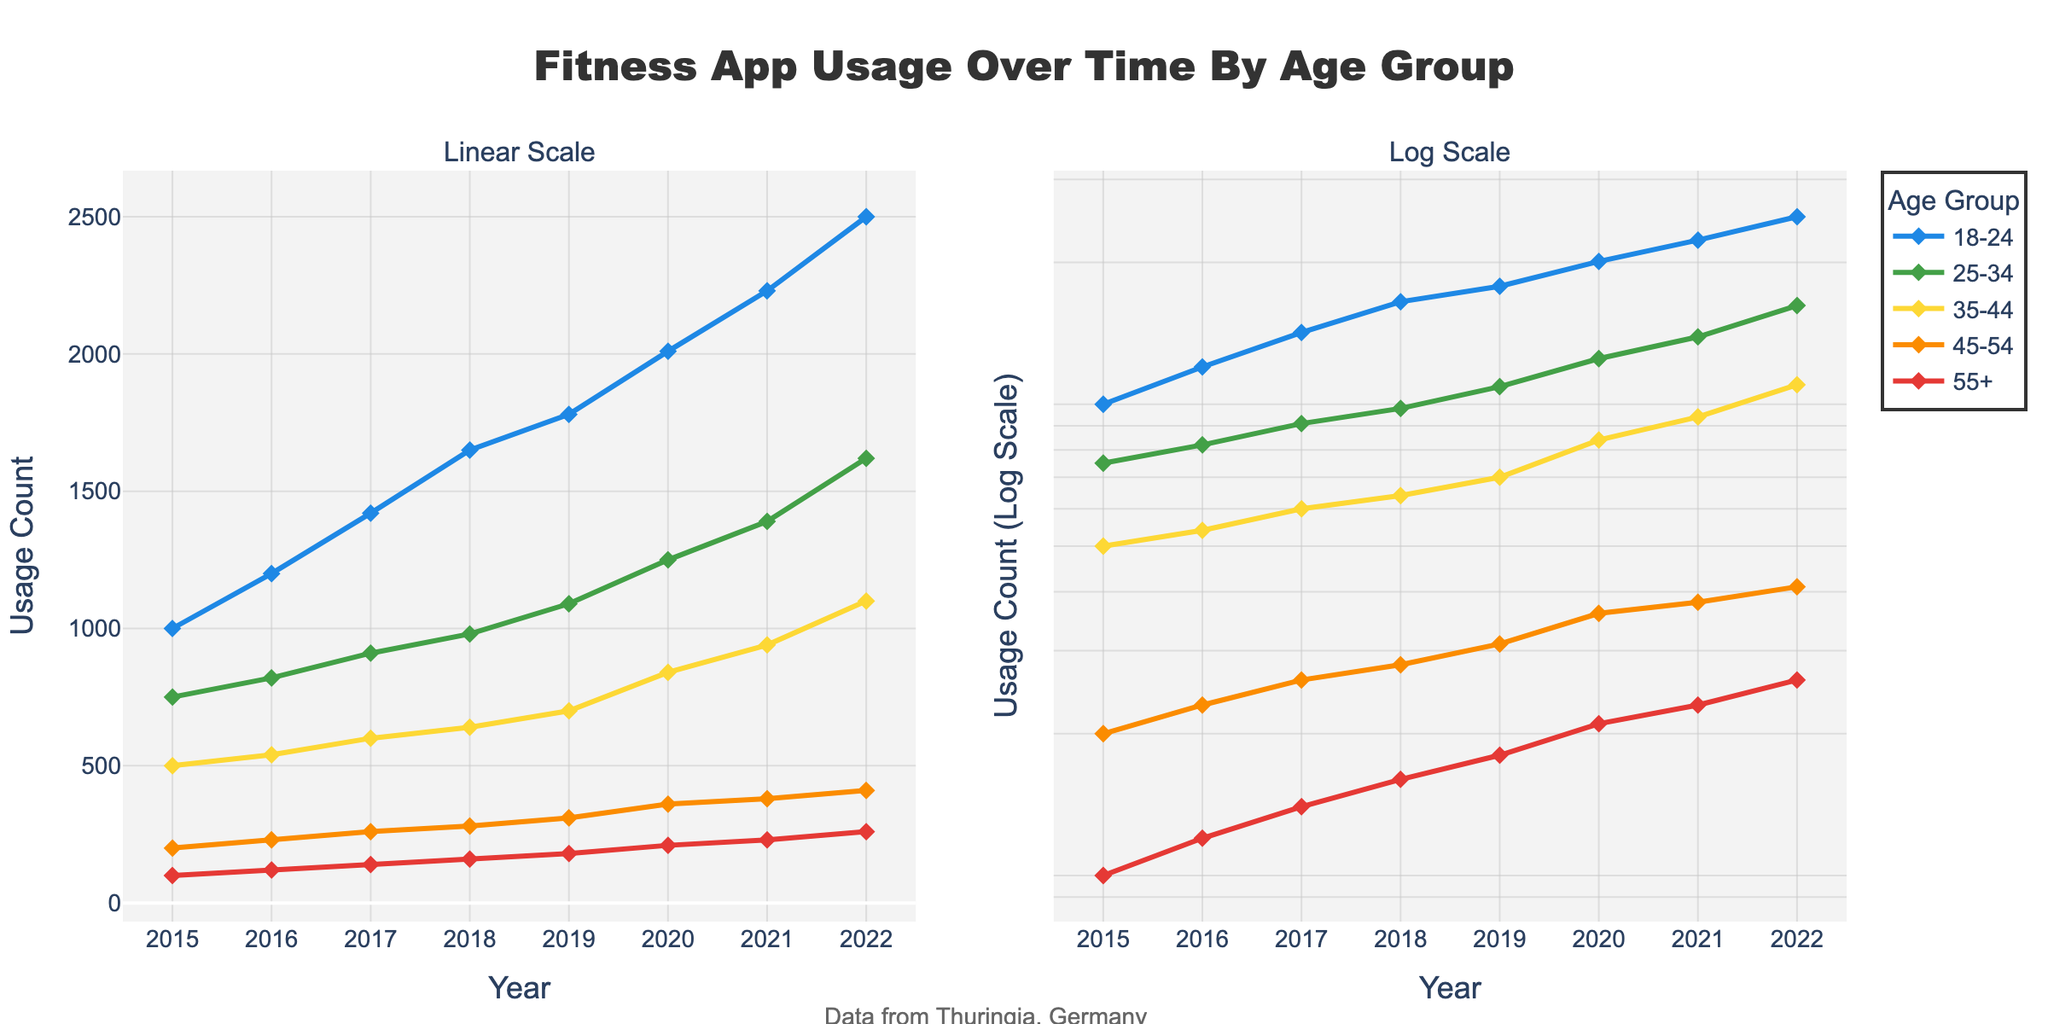What is the title of the figure? The title can be found at the top center of the figure. It reads "Fitness App Usage Over Time By Age Group".
Answer: "Fitness App Usage Over Time By Age Group" What scale types are used for the y-axes in the subplots? The left subplot uses a linear scale for the y-axis, and the right subplot uses a log scale for the y-axis, as indicated by the subplot titles.
Answer: Linear and log scale How many age groups are represented in the figure? The legend shows the different age groups, and from the colors used, we can count five distinct age groups.
Answer: Five Which age group had the highest usage count in 2022? By looking at the endpoints of the lines in 2022, we can see that the age group "18-24" has the highest usage count in both subplots.
Answer: 18-24 What is the log scale usage count for the age group 55+ in 2022? On the log scale (right subplot), the usage count for the age group 55+ in 2022 can be read directly at the 2022 mark; it's around 260.
Answer: 260 How did the usage count for the age group 25-34 change from 2015 to 2022? By comparing the start and end points of the line for age group 25-34, the usage count increased from roughly 750 in 2015 to about 1620 in 2022.
Answer: Increased from 750 to 1620 Which age group shows the steepest increase in usage count over the years? By comparing the slopes of the lines from start to finish, the age group "18-24" shows the steepest increase as evidenced by the sharp rise especially in the latter years.
Answer: 18-24 Between which years did the age group 35-44 show the largest increase in usage count? By evaluating the slope of the line for age group 35-44, the largest increase seems to be between 2020 and 2021.
Answer: 2020 to 2021 Is the usage trend of the age group 45-54 increasing or decreasing? By observing the trend of the line for the age group 45-54, it is evident that the usage count is gradually increasing over the years.
Answer: Increasing Compare the growth rate of the age groups 18-24 and 55+ using the log scale plot. In the log scale subplot on the right, the growth rate is visualized as the slope of the lines; the age group 18-24 shows a much steeper slope compared to the age group 55+.
Answer: 18-24 grows faster 